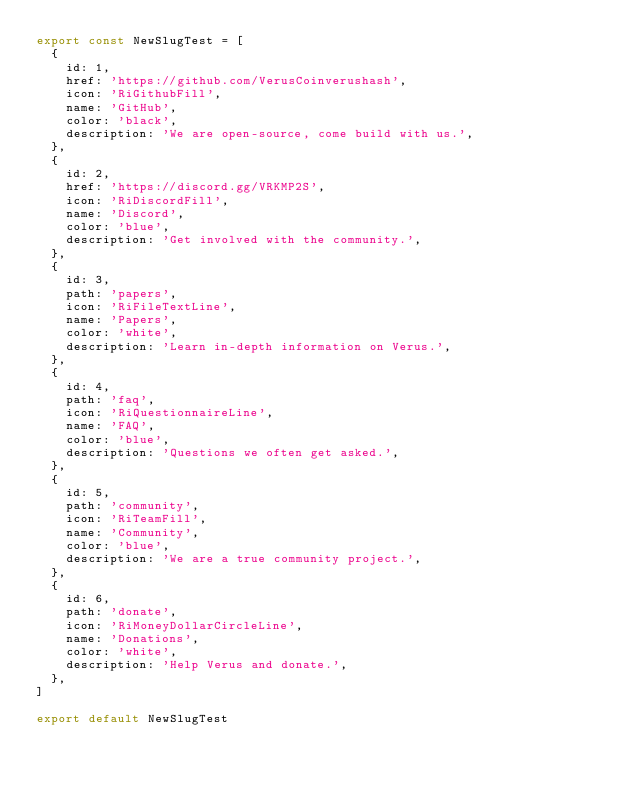<code> <loc_0><loc_0><loc_500><loc_500><_JavaScript_>export const NewSlugTest = [
  {
    id: 1,
    href: 'https://github.com/VerusCoinverushash',
    icon: 'RiGithubFill',
    name: 'GitHub',
    color: 'black',
    description: 'We are open-source, come build with us.',
  },
  {
    id: 2,
    href: 'https://discord.gg/VRKMP2S',
    icon: 'RiDiscordFill',
    name: 'Discord',
    color: 'blue',
    description: 'Get involved with the community.',
  },
  {
    id: 3,
    path: 'papers',
    icon: 'RiFileTextLine',
    name: 'Papers',
    color: 'white',
    description: 'Learn in-depth information on Verus.',
  },
  {
    id: 4,
    path: 'faq',
    icon: 'RiQuestionnaireLine',
    name: 'FAQ',
    color: 'blue',
    description: 'Questions we often get asked.',
  },
  {
    id: 5,
    path: 'community',
    icon: 'RiTeamFill',
    name: 'Community',
    color: 'blue',
    description: 'We are a true community project.',
  },
  {
    id: 6,
    path: 'donate',
    icon: 'RiMoneyDollarCircleLine',
    name: 'Donations',
    color: 'white',
    description: 'Help Verus and donate.',
  },
]

export default NewSlugTest
</code> 